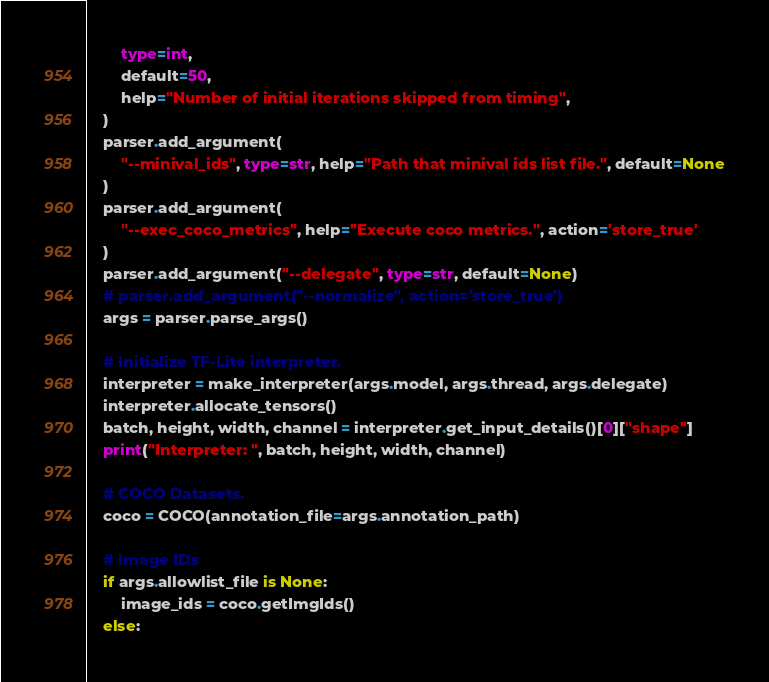Convert code to text. <code><loc_0><loc_0><loc_500><loc_500><_Python_>        type=int,
        default=50,
        help="Number of initial iterations skipped from timing",
    )
    parser.add_argument(
        "--minival_ids", type=str, help="Path that minival ids list file.", default=None
    )
    parser.add_argument(
        "--exec_coco_metrics", help="Execute coco metrics.", action='store_true'
    )
    parser.add_argument("--delegate", type=str, default=None)
    # parser.add_argument("--normalize", action='store_true')
    args = parser.parse_args()

    # Initialize TF-Lite interpreter.
    interpreter = make_interpreter(args.model, args.thread, args.delegate)
    interpreter.allocate_tensors()
    batch, height, width, channel = interpreter.get_input_details()[0]["shape"]
    print("Interpreter: ", batch, height, width, channel)

    # COCO Datasets.
    coco = COCO(annotation_file=args.annotation_path)

    # Image IDs
    if args.allowlist_file is None:
        image_ids = coco.getImgIds()
    else:</code> 